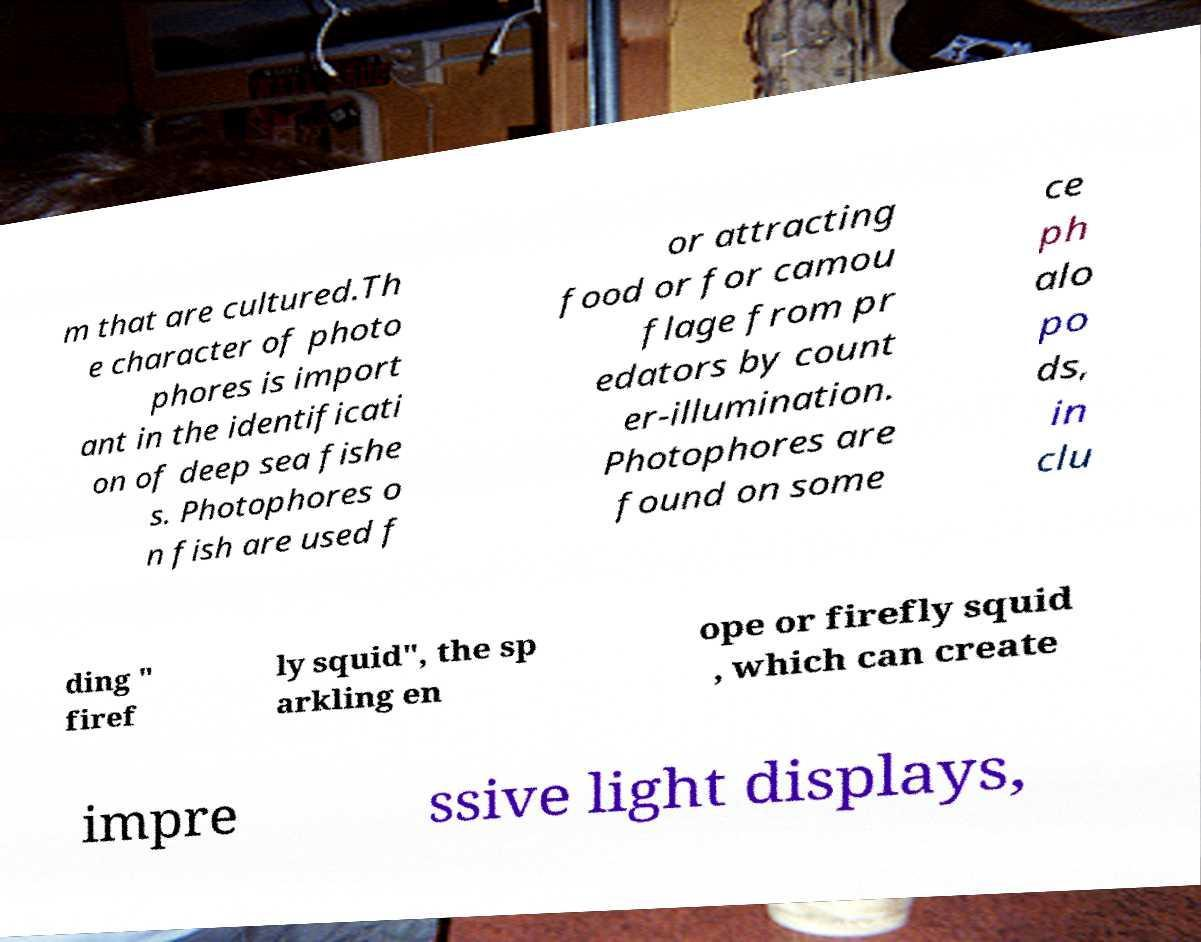What messages or text are displayed in this image? I need them in a readable, typed format. m that are cultured.Th e character of photo phores is import ant in the identificati on of deep sea fishe s. Photophores o n fish are used f or attracting food or for camou flage from pr edators by count er-illumination. Photophores are found on some ce ph alo po ds, in clu ding " firef ly squid", the sp arkling en ope or firefly squid , which can create impre ssive light displays, 